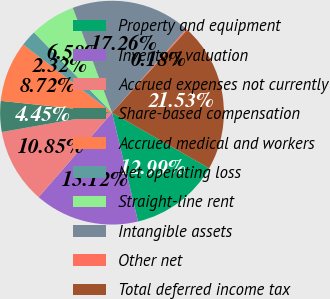<chart> <loc_0><loc_0><loc_500><loc_500><pie_chart><fcel>Property and equipment<fcel>Inventory valuation<fcel>Accrued expenses not currently<fcel>Share-based compensation<fcel>Accrued medical and workers<fcel>Net operating loss<fcel>Straight-line rent<fcel>Intangible assets<fcel>Other net<fcel>Total deferred income tax<nl><fcel>12.99%<fcel>15.12%<fcel>10.85%<fcel>4.45%<fcel>8.72%<fcel>2.32%<fcel>6.58%<fcel>17.26%<fcel>0.18%<fcel>21.53%<nl></chart> 